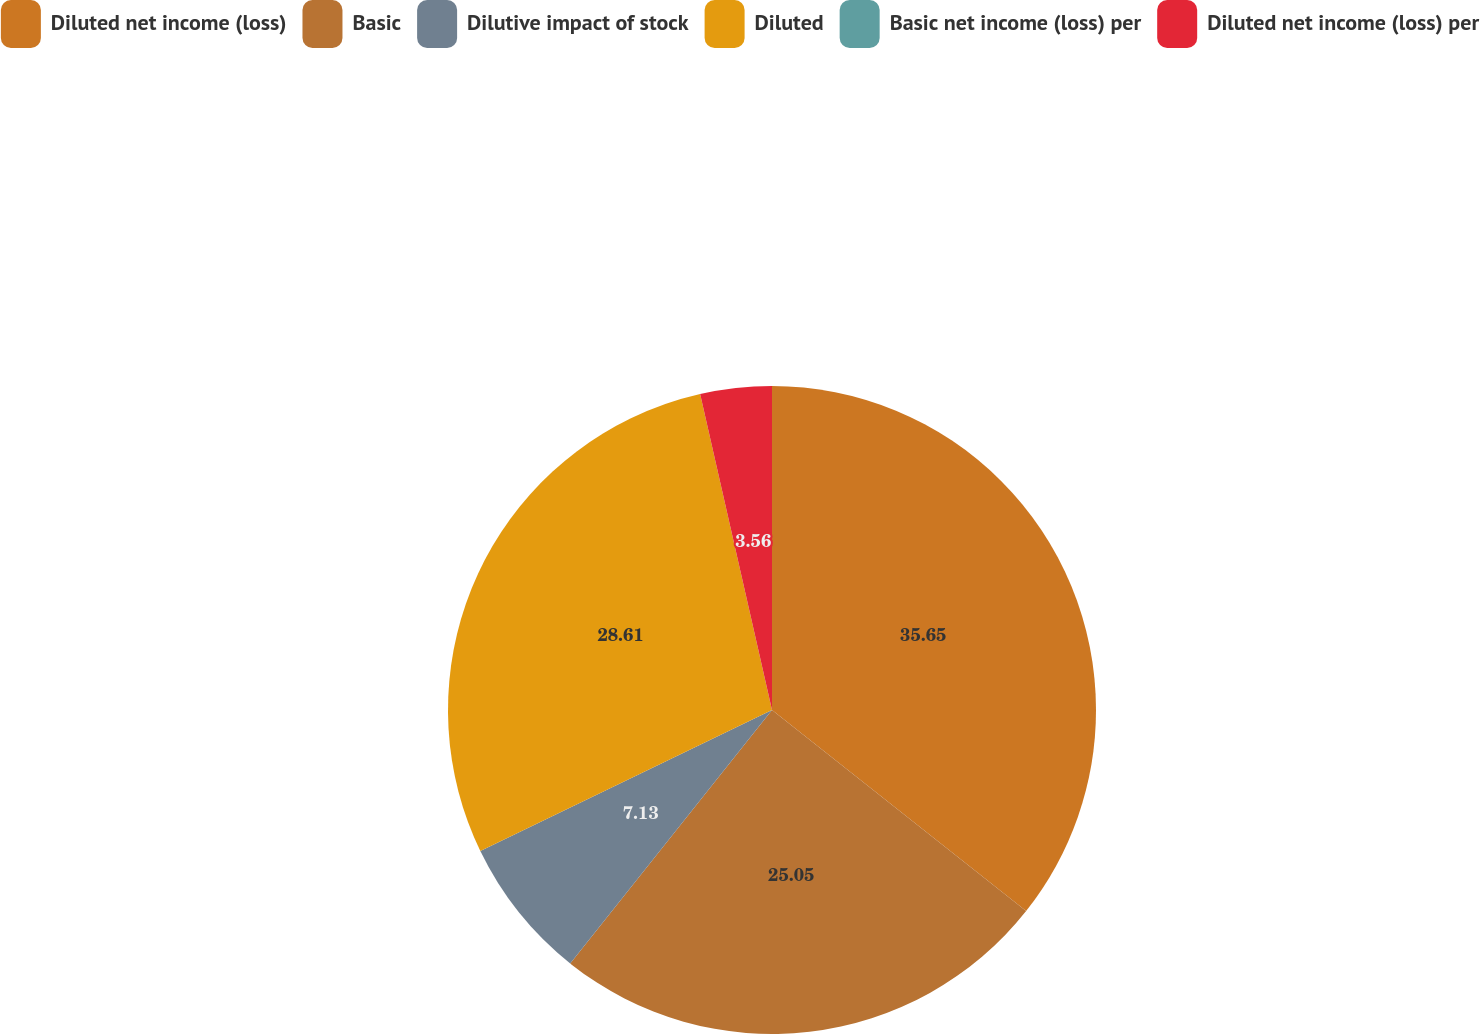Convert chart. <chart><loc_0><loc_0><loc_500><loc_500><pie_chart><fcel>Diluted net income (loss)<fcel>Basic<fcel>Dilutive impact of stock<fcel>Diluted<fcel>Basic net income (loss) per<fcel>Diluted net income (loss) per<nl><fcel>35.65%<fcel>25.05%<fcel>7.13%<fcel>28.61%<fcel>0.0%<fcel>3.56%<nl></chart> 